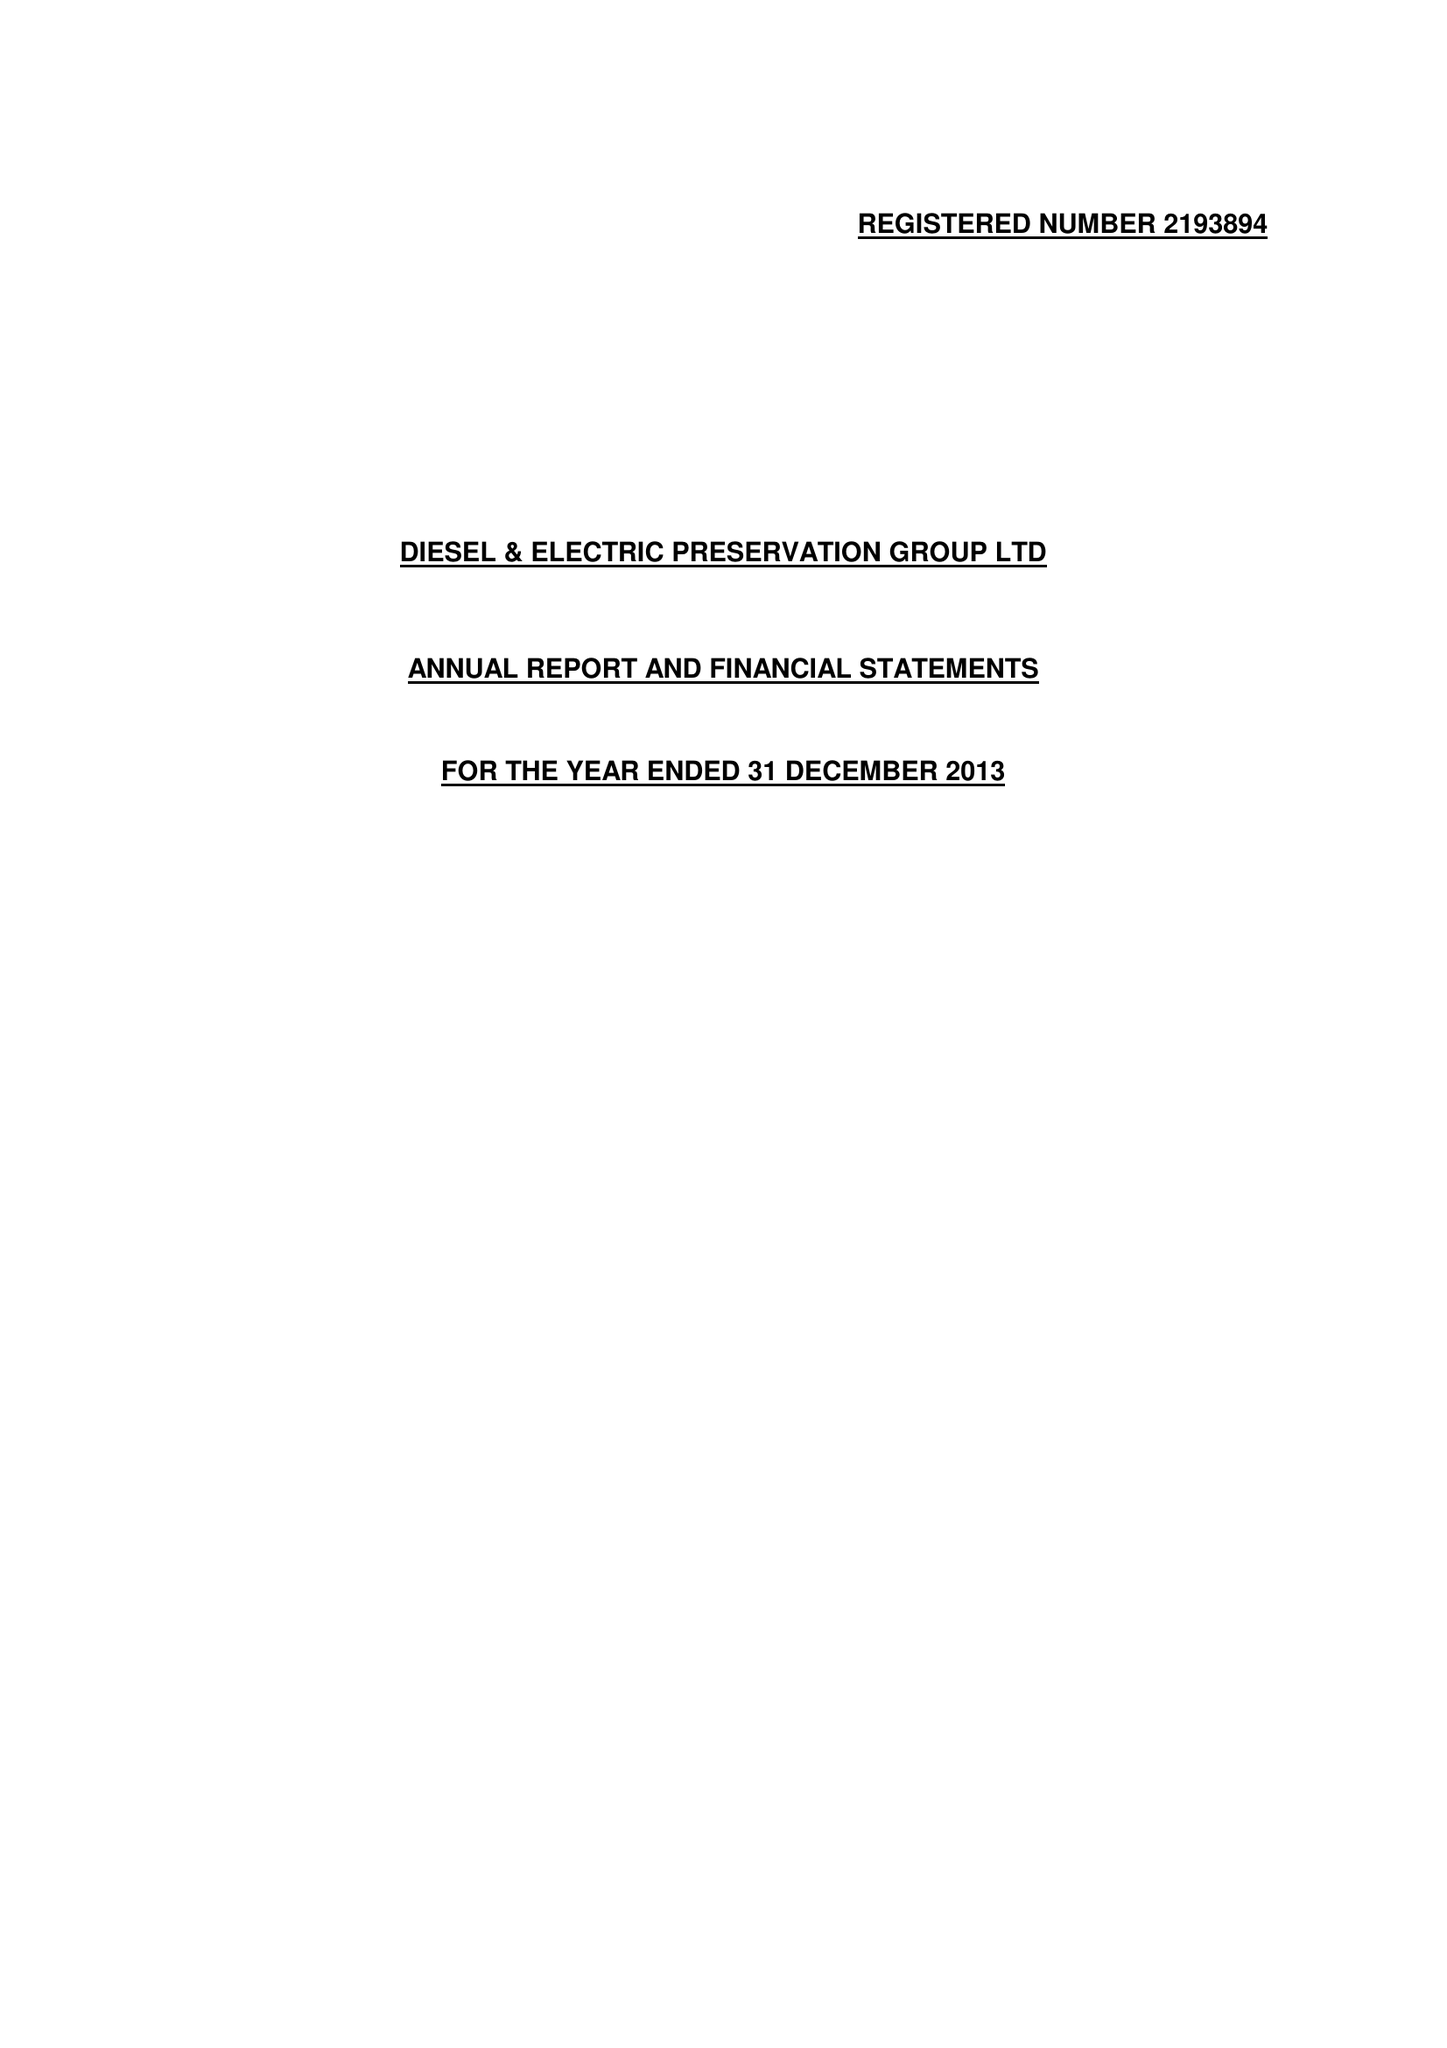What is the value for the report_date?
Answer the question using a single word or phrase. 2013-12-31 